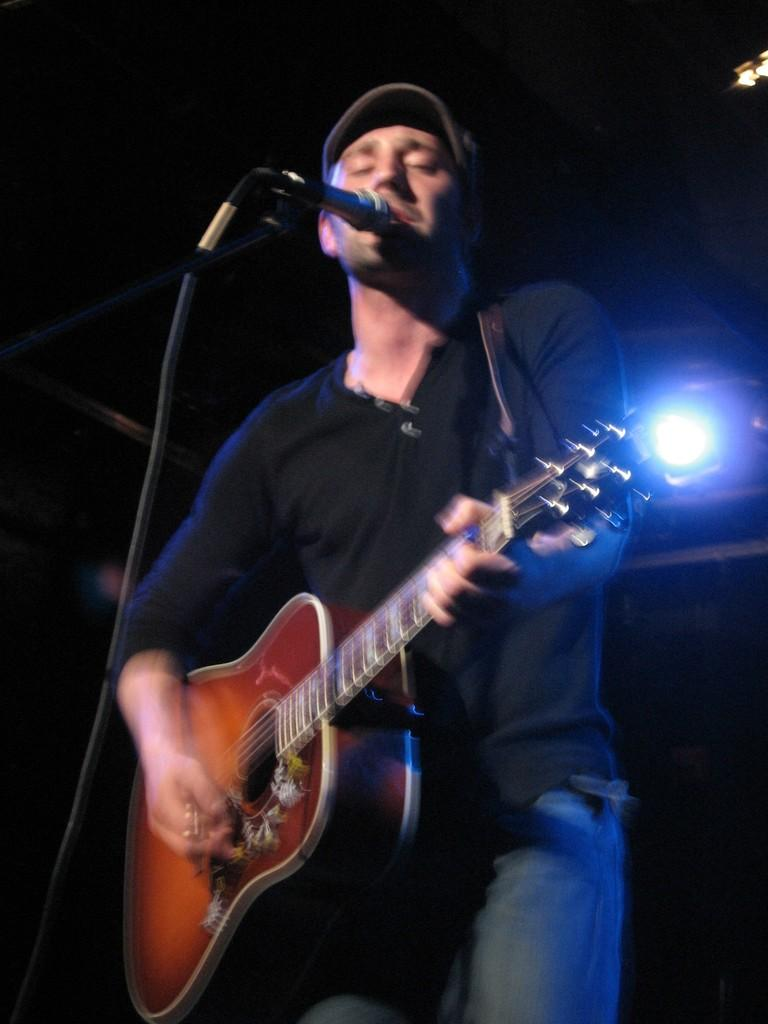What is the man in the image doing? The man is singing and playing a guitar. What is the man wearing in the image? The man is wearing a black t-shirt and a cap. What objects are present in front of the man? There is a microphone in front of the man. What can be seen behind the man in the image? There is a light behind the man. How many yaks are visible in the image? There are no yaks present in the image. What type of step is the man taking in the image? There is no indication of the man taking a step in the image, as he appears to be standing still while singing and playing the guitar. 